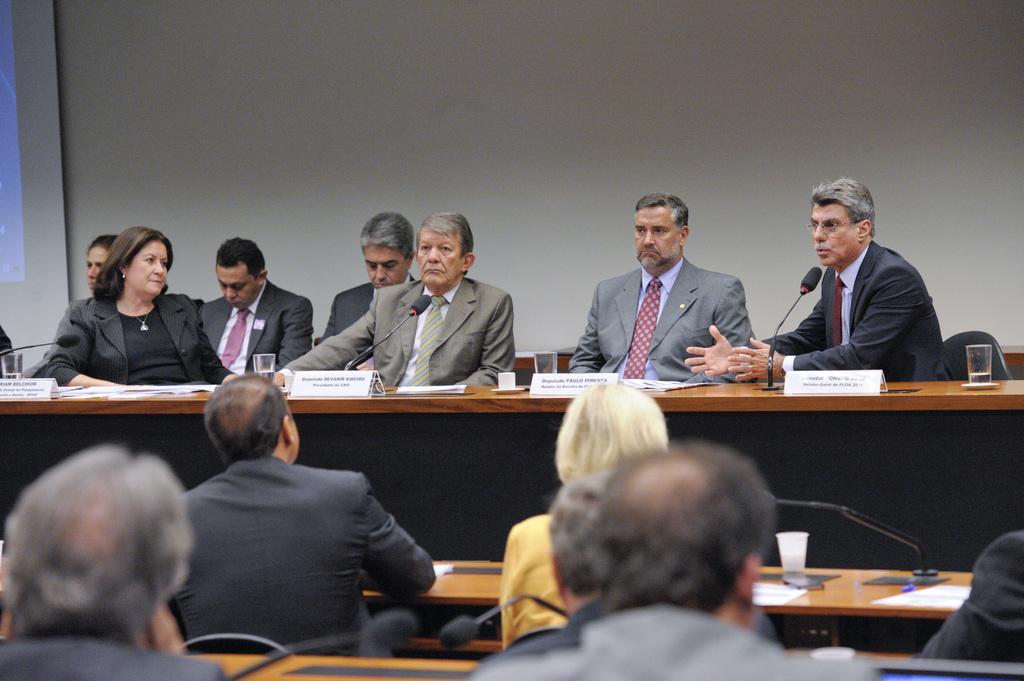Describe this image in one or two sentences. In the image we can see there are people around, wearing clothes and they are sitting. In front of them there is a desk and on the desk, we can see the glass, name plate, papers and microphones. Here we can see the wall. 